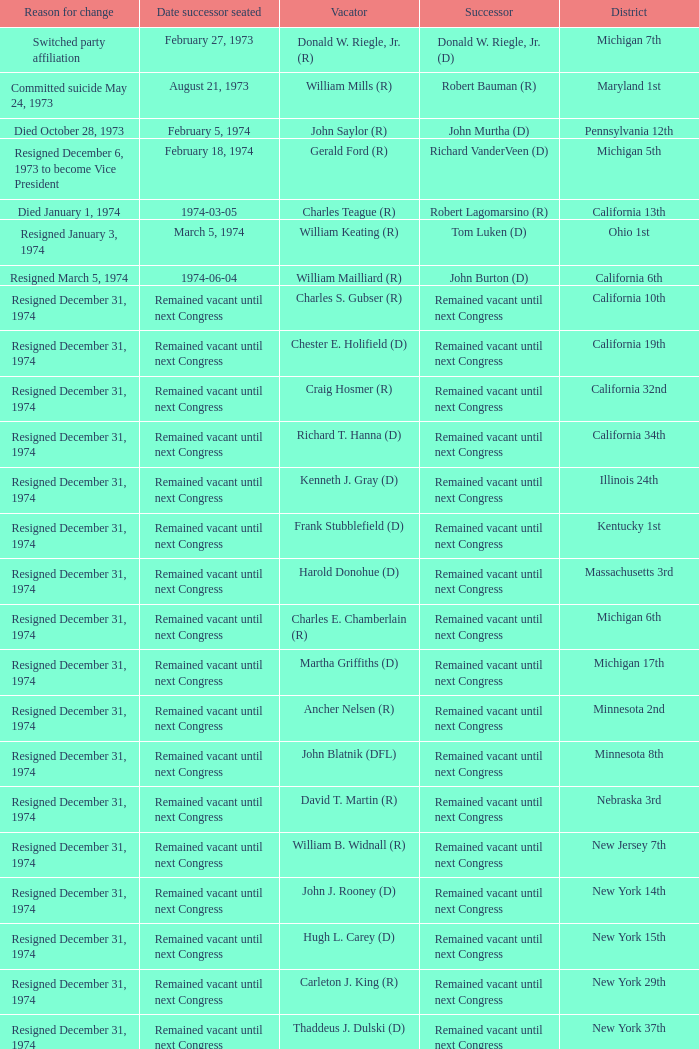Who was the vacator when the date successor seated was august 21, 1973? William Mills (R). 